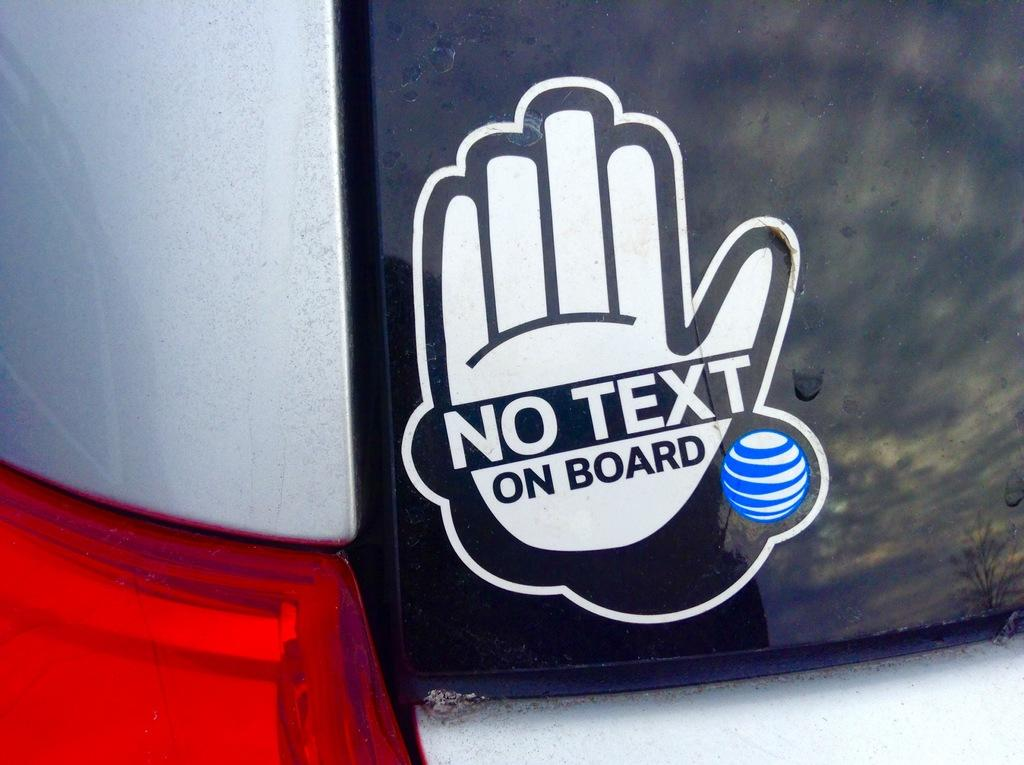What can be seen written or printed in the image? There is text visible in the image. What object is being touched by a hand in the image? There is a hand on a glass board in the image. What type of window is visible in the image? There is no window present in the image. How does the class react to the respect shown by the hand on the glass board? There is no class or indication of respect in the image; it only shows text and a hand on a glass board. 